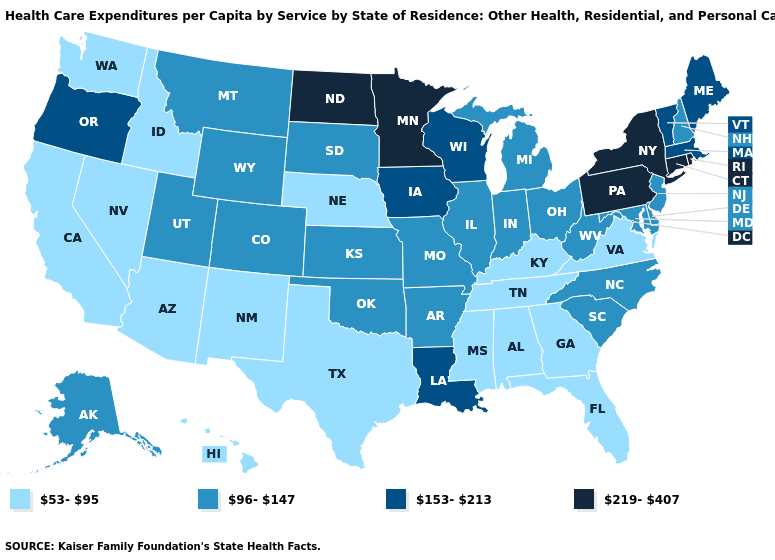What is the lowest value in states that border New York?
Short answer required. 96-147. Does North Carolina have the lowest value in the South?
Answer briefly. No. Name the states that have a value in the range 96-147?
Be succinct. Alaska, Arkansas, Colorado, Delaware, Illinois, Indiana, Kansas, Maryland, Michigan, Missouri, Montana, New Hampshire, New Jersey, North Carolina, Ohio, Oklahoma, South Carolina, South Dakota, Utah, West Virginia, Wyoming. What is the highest value in the West ?
Answer briefly. 153-213. What is the value of Connecticut?
Answer briefly. 219-407. Name the states that have a value in the range 53-95?
Answer briefly. Alabama, Arizona, California, Florida, Georgia, Hawaii, Idaho, Kentucky, Mississippi, Nebraska, Nevada, New Mexico, Tennessee, Texas, Virginia, Washington. Among the states that border California , does Oregon have the lowest value?
Be succinct. No. What is the value of South Carolina?
Be succinct. 96-147. Name the states that have a value in the range 53-95?
Give a very brief answer. Alabama, Arizona, California, Florida, Georgia, Hawaii, Idaho, Kentucky, Mississippi, Nebraska, Nevada, New Mexico, Tennessee, Texas, Virginia, Washington. Among the states that border Wyoming , does Idaho have the lowest value?
Give a very brief answer. Yes. What is the value of Oklahoma?
Be succinct. 96-147. Does Connecticut have the lowest value in the Northeast?
Write a very short answer. No. What is the value of Pennsylvania?
Concise answer only. 219-407. Among the states that border Pennsylvania , which have the highest value?
Answer briefly. New York. What is the lowest value in states that border Wisconsin?
Give a very brief answer. 96-147. 